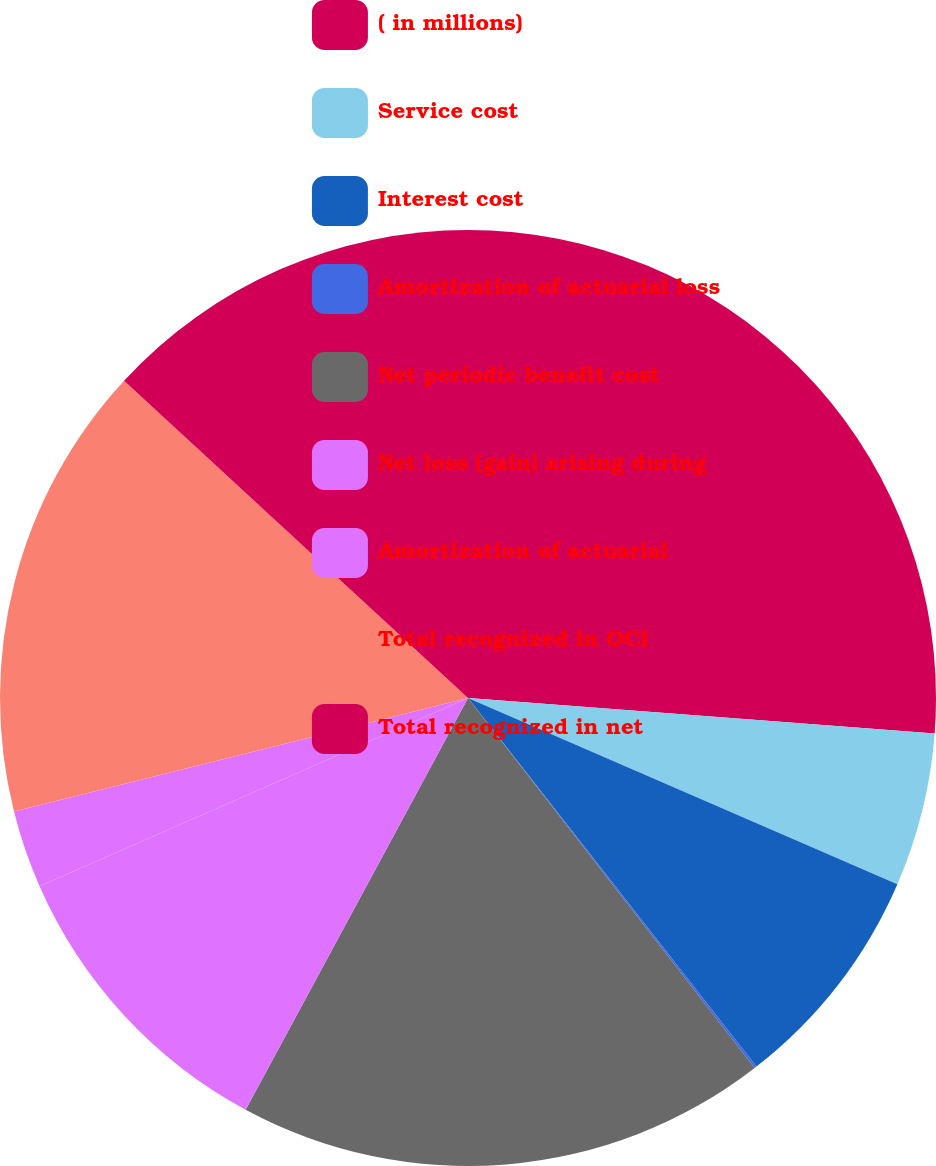Convert chart. <chart><loc_0><loc_0><loc_500><loc_500><pie_chart><fcel>( in millions)<fcel>Service cost<fcel>Interest cost<fcel>Amortization of actuarial loss<fcel>Net periodic benefit cost<fcel>Net loss (gain) arising during<fcel>Amortization of actuarial<fcel>Total recognized in OCI<fcel>Total recognized in net<nl><fcel>26.21%<fcel>5.3%<fcel>7.92%<fcel>0.08%<fcel>18.37%<fcel>10.53%<fcel>2.69%<fcel>15.76%<fcel>13.14%<nl></chart> 